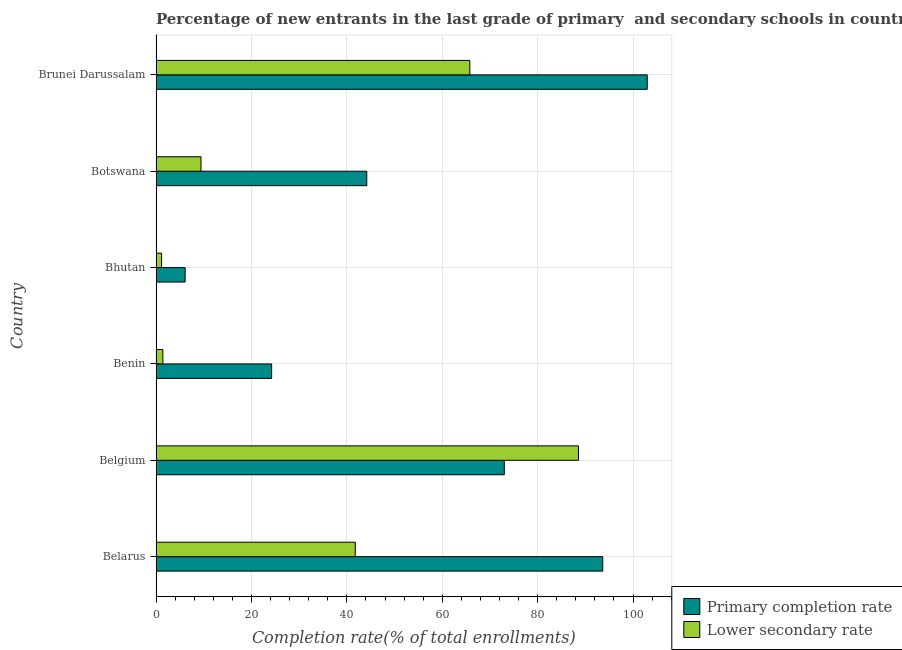How many groups of bars are there?
Your response must be concise. 6. Are the number of bars on each tick of the Y-axis equal?
Your response must be concise. Yes. What is the label of the 4th group of bars from the top?
Provide a short and direct response. Benin. In how many cases, is the number of bars for a given country not equal to the number of legend labels?
Your response must be concise. 0. What is the completion rate in primary schools in Brunei Darussalam?
Offer a terse response. 102.97. Across all countries, what is the maximum completion rate in secondary schools?
Your response must be concise. 88.56. Across all countries, what is the minimum completion rate in primary schools?
Offer a terse response. 6.1. In which country was the completion rate in primary schools minimum?
Offer a terse response. Bhutan. What is the total completion rate in secondary schools in the graph?
Give a very brief answer. 208.15. What is the difference between the completion rate in secondary schools in Belarus and that in Botswana?
Make the answer very short. 32.35. What is the difference between the completion rate in primary schools in Belgium and the completion rate in secondary schools in Brunei Darussalam?
Provide a succinct answer. 7.23. What is the average completion rate in secondary schools per country?
Make the answer very short. 34.69. What is the difference between the completion rate in secondary schools and completion rate in primary schools in Benin?
Make the answer very short. -22.8. In how many countries, is the completion rate in secondary schools greater than 36 %?
Offer a terse response. 3. What is the ratio of the completion rate in secondary schools in Botswana to that in Brunei Darussalam?
Provide a succinct answer. 0.14. Is the completion rate in secondary schools in Bhutan less than that in Brunei Darussalam?
Keep it short and to the point. Yes. Is the difference between the completion rate in secondary schools in Belarus and Benin greater than the difference between the completion rate in primary schools in Belarus and Benin?
Offer a very short reply. No. What is the difference between the highest and the second highest completion rate in secondary schools?
Keep it short and to the point. 22.78. What is the difference between the highest and the lowest completion rate in secondary schools?
Offer a terse response. 87.4. In how many countries, is the completion rate in secondary schools greater than the average completion rate in secondary schools taken over all countries?
Provide a succinct answer. 3. Is the sum of the completion rate in secondary schools in Belgium and Botswana greater than the maximum completion rate in primary schools across all countries?
Give a very brief answer. No. What does the 2nd bar from the top in Benin represents?
Ensure brevity in your answer.  Primary completion rate. What does the 2nd bar from the bottom in Brunei Darussalam represents?
Provide a succinct answer. Lower secondary rate. How many bars are there?
Keep it short and to the point. 12. Are all the bars in the graph horizontal?
Offer a terse response. Yes. Does the graph contain grids?
Make the answer very short. Yes. Where does the legend appear in the graph?
Provide a succinct answer. Bottom right. How many legend labels are there?
Give a very brief answer. 2. What is the title of the graph?
Offer a terse response. Percentage of new entrants in the last grade of primary  and secondary schools in countries. Does "Number of arrivals" appear as one of the legend labels in the graph?
Make the answer very short. No. What is the label or title of the X-axis?
Keep it short and to the point. Completion rate(% of total enrollments). What is the Completion rate(% of total enrollments) of Primary completion rate in Belarus?
Make the answer very short. 93.64. What is the Completion rate(% of total enrollments) in Lower secondary rate in Belarus?
Your answer should be very brief. 41.77. What is the Completion rate(% of total enrollments) of Primary completion rate in Belgium?
Provide a short and direct response. 73.01. What is the Completion rate(% of total enrollments) in Lower secondary rate in Belgium?
Keep it short and to the point. 88.56. What is the Completion rate(% of total enrollments) of Primary completion rate in Benin?
Keep it short and to the point. 24.24. What is the Completion rate(% of total enrollments) of Lower secondary rate in Benin?
Your answer should be very brief. 1.44. What is the Completion rate(% of total enrollments) in Primary completion rate in Bhutan?
Make the answer very short. 6.1. What is the Completion rate(% of total enrollments) of Lower secondary rate in Bhutan?
Your answer should be very brief. 1.16. What is the Completion rate(% of total enrollments) in Primary completion rate in Botswana?
Your answer should be very brief. 44.17. What is the Completion rate(% of total enrollments) in Lower secondary rate in Botswana?
Keep it short and to the point. 9.43. What is the Completion rate(% of total enrollments) of Primary completion rate in Brunei Darussalam?
Provide a succinct answer. 102.97. What is the Completion rate(% of total enrollments) of Lower secondary rate in Brunei Darussalam?
Keep it short and to the point. 65.78. Across all countries, what is the maximum Completion rate(% of total enrollments) of Primary completion rate?
Keep it short and to the point. 102.97. Across all countries, what is the maximum Completion rate(% of total enrollments) in Lower secondary rate?
Offer a terse response. 88.56. Across all countries, what is the minimum Completion rate(% of total enrollments) in Primary completion rate?
Make the answer very short. 6.1. Across all countries, what is the minimum Completion rate(% of total enrollments) in Lower secondary rate?
Provide a short and direct response. 1.16. What is the total Completion rate(% of total enrollments) in Primary completion rate in the graph?
Ensure brevity in your answer.  344.14. What is the total Completion rate(% of total enrollments) of Lower secondary rate in the graph?
Give a very brief answer. 208.15. What is the difference between the Completion rate(% of total enrollments) in Primary completion rate in Belarus and that in Belgium?
Your answer should be very brief. 20.63. What is the difference between the Completion rate(% of total enrollments) in Lower secondary rate in Belarus and that in Belgium?
Give a very brief answer. -46.79. What is the difference between the Completion rate(% of total enrollments) of Primary completion rate in Belarus and that in Benin?
Provide a succinct answer. 69.41. What is the difference between the Completion rate(% of total enrollments) of Lower secondary rate in Belarus and that in Benin?
Your answer should be very brief. 40.34. What is the difference between the Completion rate(% of total enrollments) of Primary completion rate in Belarus and that in Bhutan?
Your answer should be compact. 87.54. What is the difference between the Completion rate(% of total enrollments) in Lower secondary rate in Belarus and that in Bhutan?
Provide a succinct answer. 40.61. What is the difference between the Completion rate(% of total enrollments) of Primary completion rate in Belarus and that in Botswana?
Provide a short and direct response. 49.47. What is the difference between the Completion rate(% of total enrollments) in Lower secondary rate in Belarus and that in Botswana?
Offer a very short reply. 32.35. What is the difference between the Completion rate(% of total enrollments) in Primary completion rate in Belarus and that in Brunei Darussalam?
Your response must be concise. -9.33. What is the difference between the Completion rate(% of total enrollments) in Lower secondary rate in Belarus and that in Brunei Darussalam?
Your answer should be compact. -24.01. What is the difference between the Completion rate(% of total enrollments) in Primary completion rate in Belgium and that in Benin?
Give a very brief answer. 48.77. What is the difference between the Completion rate(% of total enrollments) of Lower secondary rate in Belgium and that in Benin?
Your response must be concise. 87.12. What is the difference between the Completion rate(% of total enrollments) in Primary completion rate in Belgium and that in Bhutan?
Keep it short and to the point. 66.91. What is the difference between the Completion rate(% of total enrollments) in Lower secondary rate in Belgium and that in Bhutan?
Keep it short and to the point. 87.4. What is the difference between the Completion rate(% of total enrollments) of Primary completion rate in Belgium and that in Botswana?
Give a very brief answer. 28.84. What is the difference between the Completion rate(% of total enrollments) of Lower secondary rate in Belgium and that in Botswana?
Keep it short and to the point. 79.13. What is the difference between the Completion rate(% of total enrollments) of Primary completion rate in Belgium and that in Brunei Darussalam?
Keep it short and to the point. -29.96. What is the difference between the Completion rate(% of total enrollments) of Lower secondary rate in Belgium and that in Brunei Darussalam?
Make the answer very short. 22.78. What is the difference between the Completion rate(% of total enrollments) of Primary completion rate in Benin and that in Bhutan?
Your answer should be very brief. 18.14. What is the difference between the Completion rate(% of total enrollments) of Lower secondary rate in Benin and that in Bhutan?
Offer a terse response. 0.27. What is the difference between the Completion rate(% of total enrollments) in Primary completion rate in Benin and that in Botswana?
Your answer should be very brief. -19.94. What is the difference between the Completion rate(% of total enrollments) of Lower secondary rate in Benin and that in Botswana?
Offer a very short reply. -7.99. What is the difference between the Completion rate(% of total enrollments) of Primary completion rate in Benin and that in Brunei Darussalam?
Make the answer very short. -78.73. What is the difference between the Completion rate(% of total enrollments) of Lower secondary rate in Benin and that in Brunei Darussalam?
Your answer should be compact. -64.35. What is the difference between the Completion rate(% of total enrollments) of Primary completion rate in Bhutan and that in Botswana?
Offer a terse response. -38.07. What is the difference between the Completion rate(% of total enrollments) in Lower secondary rate in Bhutan and that in Botswana?
Your response must be concise. -8.26. What is the difference between the Completion rate(% of total enrollments) of Primary completion rate in Bhutan and that in Brunei Darussalam?
Offer a very short reply. -96.87. What is the difference between the Completion rate(% of total enrollments) of Lower secondary rate in Bhutan and that in Brunei Darussalam?
Offer a very short reply. -64.62. What is the difference between the Completion rate(% of total enrollments) of Primary completion rate in Botswana and that in Brunei Darussalam?
Offer a terse response. -58.8. What is the difference between the Completion rate(% of total enrollments) of Lower secondary rate in Botswana and that in Brunei Darussalam?
Offer a terse response. -56.36. What is the difference between the Completion rate(% of total enrollments) of Primary completion rate in Belarus and the Completion rate(% of total enrollments) of Lower secondary rate in Belgium?
Make the answer very short. 5.08. What is the difference between the Completion rate(% of total enrollments) of Primary completion rate in Belarus and the Completion rate(% of total enrollments) of Lower secondary rate in Benin?
Ensure brevity in your answer.  92.21. What is the difference between the Completion rate(% of total enrollments) of Primary completion rate in Belarus and the Completion rate(% of total enrollments) of Lower secondary rate in Bhutan?
Offer a very short reply. 92.48. What is the difference between the Completion rate(% of total enrollments) in Primary completion rate in Belarus and the Completion rate(% of total enrollments) in Lower secondary rate in Botswana?
Give a very brief answer. 84.22. What is the difference between the Completion rate(% of total enrollments) in Primary completion rate in Belarus and the Completion rate(% of total enrollments) in Lower secondary rate in Brunei Darussalam?
Offer a very short reply. 27.86. What is the difference between the Completion rate(% of total enrollments) in Primary completion rate in Belgium and the Completion rate(% of total enrollments) in Lower secondary rate in Benin?
Keep it short and to the point. 71.57. What is the difference between the Completion rate(% of total enrollments) in Primary completion rate in Belgium and the Completion rate(% of total enrollments) in Lower secondary rate in Bhutan?
Offer a terse response. 71.85. What is the difference between the Completion rate(% of total enrollments) in Primary completion rate in Belgium and the Completion rate(% of total enrollments) in Lower secondary rate in Botswana?
Offer a very short reply. 63.58. What is the difference between the Completion rate(% of total enrollments) of Primary completion rate in Belgium and the Completion rate(% of total enrollments) of Lower secondary rate in Brunei Darussalam?
Offer a terse response. 7.23. What is the difference between the Completion rate(% of total enrollments) of Primary completion rate in Benin and the Completion rate(% of total enrollments) of Lower secondary rate in Bhutan?
Offer a very short reply. 23.07. What is the difference between the Completion rate(% of total enrollments) of Primary completion rate in Benin and the Completion rate(% of total enrollments) of Lower secondary rate in Botswana?
Your response must be concise. 14.81. What is the difference between the Completion rate(% of total enrollments) in Primary completion rate in Benin and the Completion rate(% of total enrollments) in Lower secondary rate in Brunei Darussalam?
Your answer should be very brief. -41.55. What is the difference between the Completion rate(% of total enrollments) of Primary completion rate in Bhutan and the Completion rate(% of total enrollments) of Lower secondary rate in Botswana?
Your response must be concise. -3.33. What is the difference between the Completion rate(% of total enrollments) in Primary completion rate in Bhutan and the Completion rate(% of total enrollments) in Lower secondary rate in Brunei Darussalam?
Your answer should be compact. -59.68. What is the difference between the Completion rate(% of total enrollments) in Primary completion rate in Botswana and the Completion rate(% of total enrollments) in Lower secondary rate in Brunei Darussalam?
Ensure brevity in your answer.  -21.61. What is the average Completion rate(% of total enrollments) in Primary completion rate per country?
Ensure brevity in your answer.  57.36. What is the average Completion rate(% of total enrollments) of Lower secondary rate per country?
Give a very brief answer. 34.69. What is the difference between the Completion rate(% of total enrollments) in Primary completion rate and Completion rate(% of total enrollments) in Lower secondary rate in Belarus?
Keep it short and to the point. 51.87. What is the difference between the Completion rate(% of total enrollments) of Primary completion rate and Completion rate(% of total enrollments) of Lower secondary rate in Belgium?
Provide a succinct answer. -15.55. What is the difference between the Completion rate(% of total enrollments) of Primary completion rate and Completion rate(% of total enrollments) of Lower secondary rate in Benin?
Make the answer very short. 22.8. What is the difference between the Completion rate(% of total enrollments) in Primary completion rate and Completion rate(% of total enrollments) in Lower secondary rate in Bhutan?
Your response must be concise. 4.94. What is the difference between the Completion rate(% of total enrollments) in Primary completion rate and Completion rate(% of total enrollments) in Lower secondary rate in Botswana?
Provide a succinct answer. 34.75. What is the difference between the Completion rate(% of total enrollments) of Primary completion rate and Completion rate(% of total enrollments) of Lower secondary rate in Brunei Darussalam?
Make the answer very short. 37.19. What is the ratio of the Completion rate(% of total enrollments) of Primary completion rate in Belarus to that in Belgium?
Ensure brevity in your answer.  1.28. What is the ratio of the Completion rate(% of total enrollments) in Lower secondary rate in Belarus to that in Belgium?
Give a very brief answer. 0.47. What is the ratio of the Completion rate(% of total enrollments) in Primary completion rate in Belarus to that in Benin?
Keep it short and to the point. 3.86. What is the ratio of the Completion rate(% of total enrollments) of Lower secondary rate in Belarus to that in Benin?
Your response must be concise. 29.06. What is the ratio of the Completion rate(% of total enrollments) of Primary completion rate in Belarus to that in Bhutan?
Ensure brevity in your answer.  15.35. What is the ratio of the Completion rate(% of total enrollments) of Lower secondary rate in Belarus to that in Bhutan?
Your answer should be very brief. 35.87. What is the ratio of the Completion rate(% of total enrollments) of Primary completion rate in Belarus to that in Botswana?
Your response must be concise. 2.12. What is the ratio of the Completion rate(% of total enrollments) in Lower secondary rate in Belarus to that in Botswana?
Give a very brief answer. 4.43. What is the ratio of the Completion rate(% of total enrollments) of Primary completion rate in Belarus to that in Brunei Darussalam?
Offer a terse response. 0.91. What is the ratio of the Completion rate(% of total enrollments) in Lower secondary rate in Belarus to that in Brunei Darussalam?
Provide a succinct answer. 0.64. What is the ratio of the Completion rate(% of total enrollments) in Primary completion rate in Belgium to that in Benin?
Your answer should be very brief. 3.01. What is the ratio of the Completion rate(% of total enrollments) of Lower secondary rate in Belgium to that in Benin?
Give a very brief answer. 61.6. What is the ratio of the Completion rate(% of total enrollments) of Primary completion rate in Belgium to that in Bhutan?
Give a very brief answer. 11.97. What is the ratio of the Completion rate(% of total enrollments) in Lower secondary rate in Belgium to that in Bhutan?
Make the answer very short. 76.04. What is the ratio of the Completion rate(% of total enrollments) of Primary completion rate in Belgium to that in Botswana?
Your response must be concise. 1.65. What is the ratio of the Completion rate(% of total enrollments) in Lower secondary rate in Belgium to that in Botswana?
Make the answer very short. 9.39. What is the ratio of the Completion rate(% of total enrollments) in Primary completion rate in Belgium to that in Brunei Darussalam?
Provide a succinct answer. 0.71. What is the ratio of the Completion rate(% of total enrollments) of Lower secondary rate in Belgium to that in Brunei Darussalam?
Make the answer very short. 1.35. What is the ratio of the Completion rate(% of total enrollments) in Primary completion rate in Benin to that in Bhutan?
Provide a succinct answer. 3.97. What is the ratio of the Completion rate(% of total enrollments) in Lower secondary rate in Benin to that in Bhutan?
Provide a succinct answer. 1.23. What is the ratio of the Completion rate(% of total enrollments) in Primary completion rate in Benin to that in Botswana?
Your response must be concise. 0.55. What is the ratio of the Completion rate(% of total enrollments) of Lower secondary rate in Benin to that in Botswana?
Offer a terse response. 0.15. What is the ratio of the Completion rate(% of total enrollments) of Primary completion rate in Benin to that in Brunei Darussalam?
Give a very brief answer. 0.24. What is the ratio of the Completion rate(% of total enrollments) of Lower secondary rate in Benin to that in Brunei Darussalam?
Provide a short and direct response. 0.02. What is the ratio of the Completion rate(% of total enrollments) of Primary completion rate in Bhutan to that in Botswana?
Keep it short and to the point. 0.14. What is the ratio of the Completion rate(% of total enrollments) in Lower secondary rate in Bhutan to that in Botswana?
Your answer should be very brief. 0.12. What is the ratio of the Completion rate(% of total enrollments) in Primary completion rate in Bhutan to that in Brunei Darussalam?
Offer a very short reply. 0.06. What is the ratio of the Completion rate(% of total enrollments) in Lower secondary rate in Bhutan to that in Brunei Darussalam?
Your response must be concise. 0.02. What is the ratio of the Completion rate(% of total enrollments) in Primary completion rate in Botswana to that in Brunei Darussalam?
Offer a terse response. 0.43. What is the ratio of the Completion rate(% of total enrollments) in Lower secondary rate in Botswana to that in Brunei Darussalam?
Your answer should be compact. 0.14. What is the difference between the highest and the second highest Completion rate(% of total enrollments) of Primary completion rate?
Provide a succinct answer. 9.33. What is the difference between the highest and the second highest Completion rate(% of total enrollments) in Lower secondary rate?
Make the answer very short. 22.78. What is the difference between the highest and the lowest Completion rate(% of total enrollments) in Primary completion rate?
Provide a succinct answer. 96.87. What is the difference between the highest and the lowest Completion rate(% of total enrollments) in Lower secondary rate?
Your response must be concise. 87.4. 